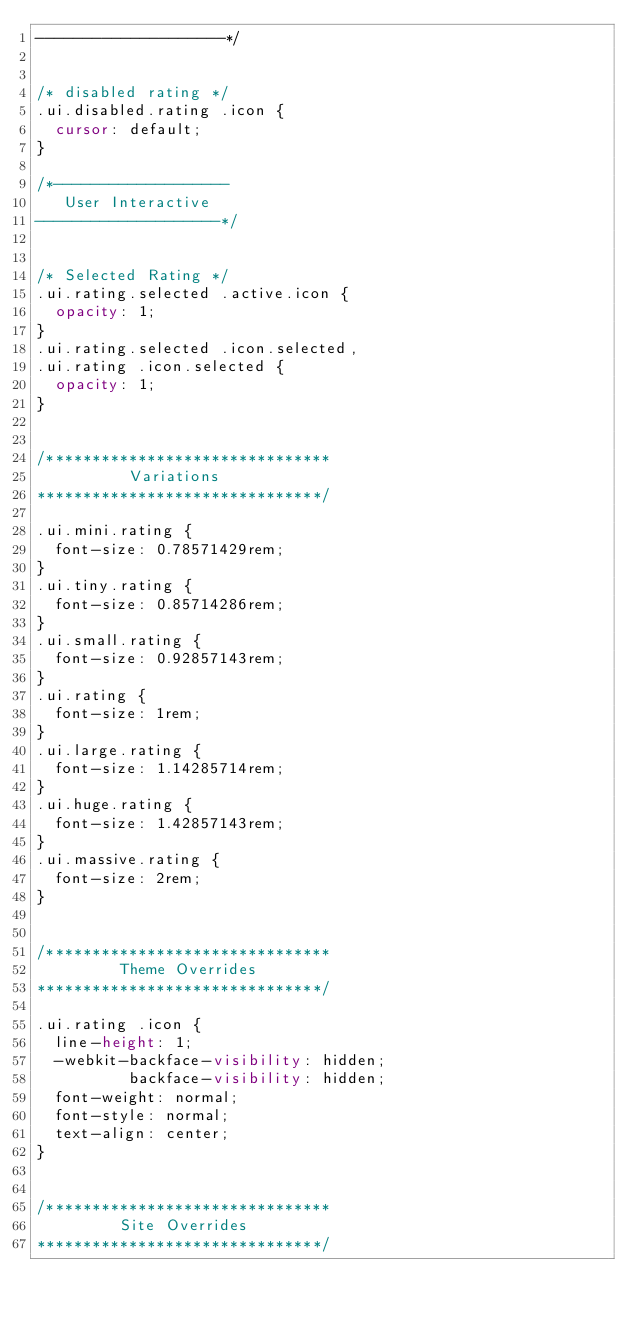Convert code to text. <code><loc_0><loc_0><loc_500><loc_500><_CSS_>--------------------*/


/* disabled rating */
.ui.disabled.rating .icon {
  cursor: default;
}

/*-------------------
   User Interactive
--------------------*/


/* Selected Rating */
.ui.rating.selected .active.icon {
  opacity: 1;
}
.ui.rating.selected .icon.selected,
.ui.rating .icon.selected {
  opacity: 1;
}


/*******************************
          Variations
*******************************/

.ui.mini.rating {
  font-size: 0.78571429rem;
}
.ui.tiny.rating {
  font-size: 0.85714286rem;
}
.ui.small.rating {
  font-size: 0.92857143rem;
}
.ui.rating {
  font-size: 1rem;
}
.ui.large.rating {
  font-size: 1.14285714rem;
}
.ui.huge.rating {
  font-size: 1.42857143rem;
}
.ui.massive.rating {
  font-size: 2rem;
}


/*******************************
         Theme Overrides
*******************************/

.ui.rating .icon {
  line-height: 1;
  -webkit-backface-visibility: hidden;
          backface-visibility: hidden;
  font-weight: normal;
  font-style: normal;
  text-align: center;
}


/*******************************
         Site Overrides
*******************************/

</code> 